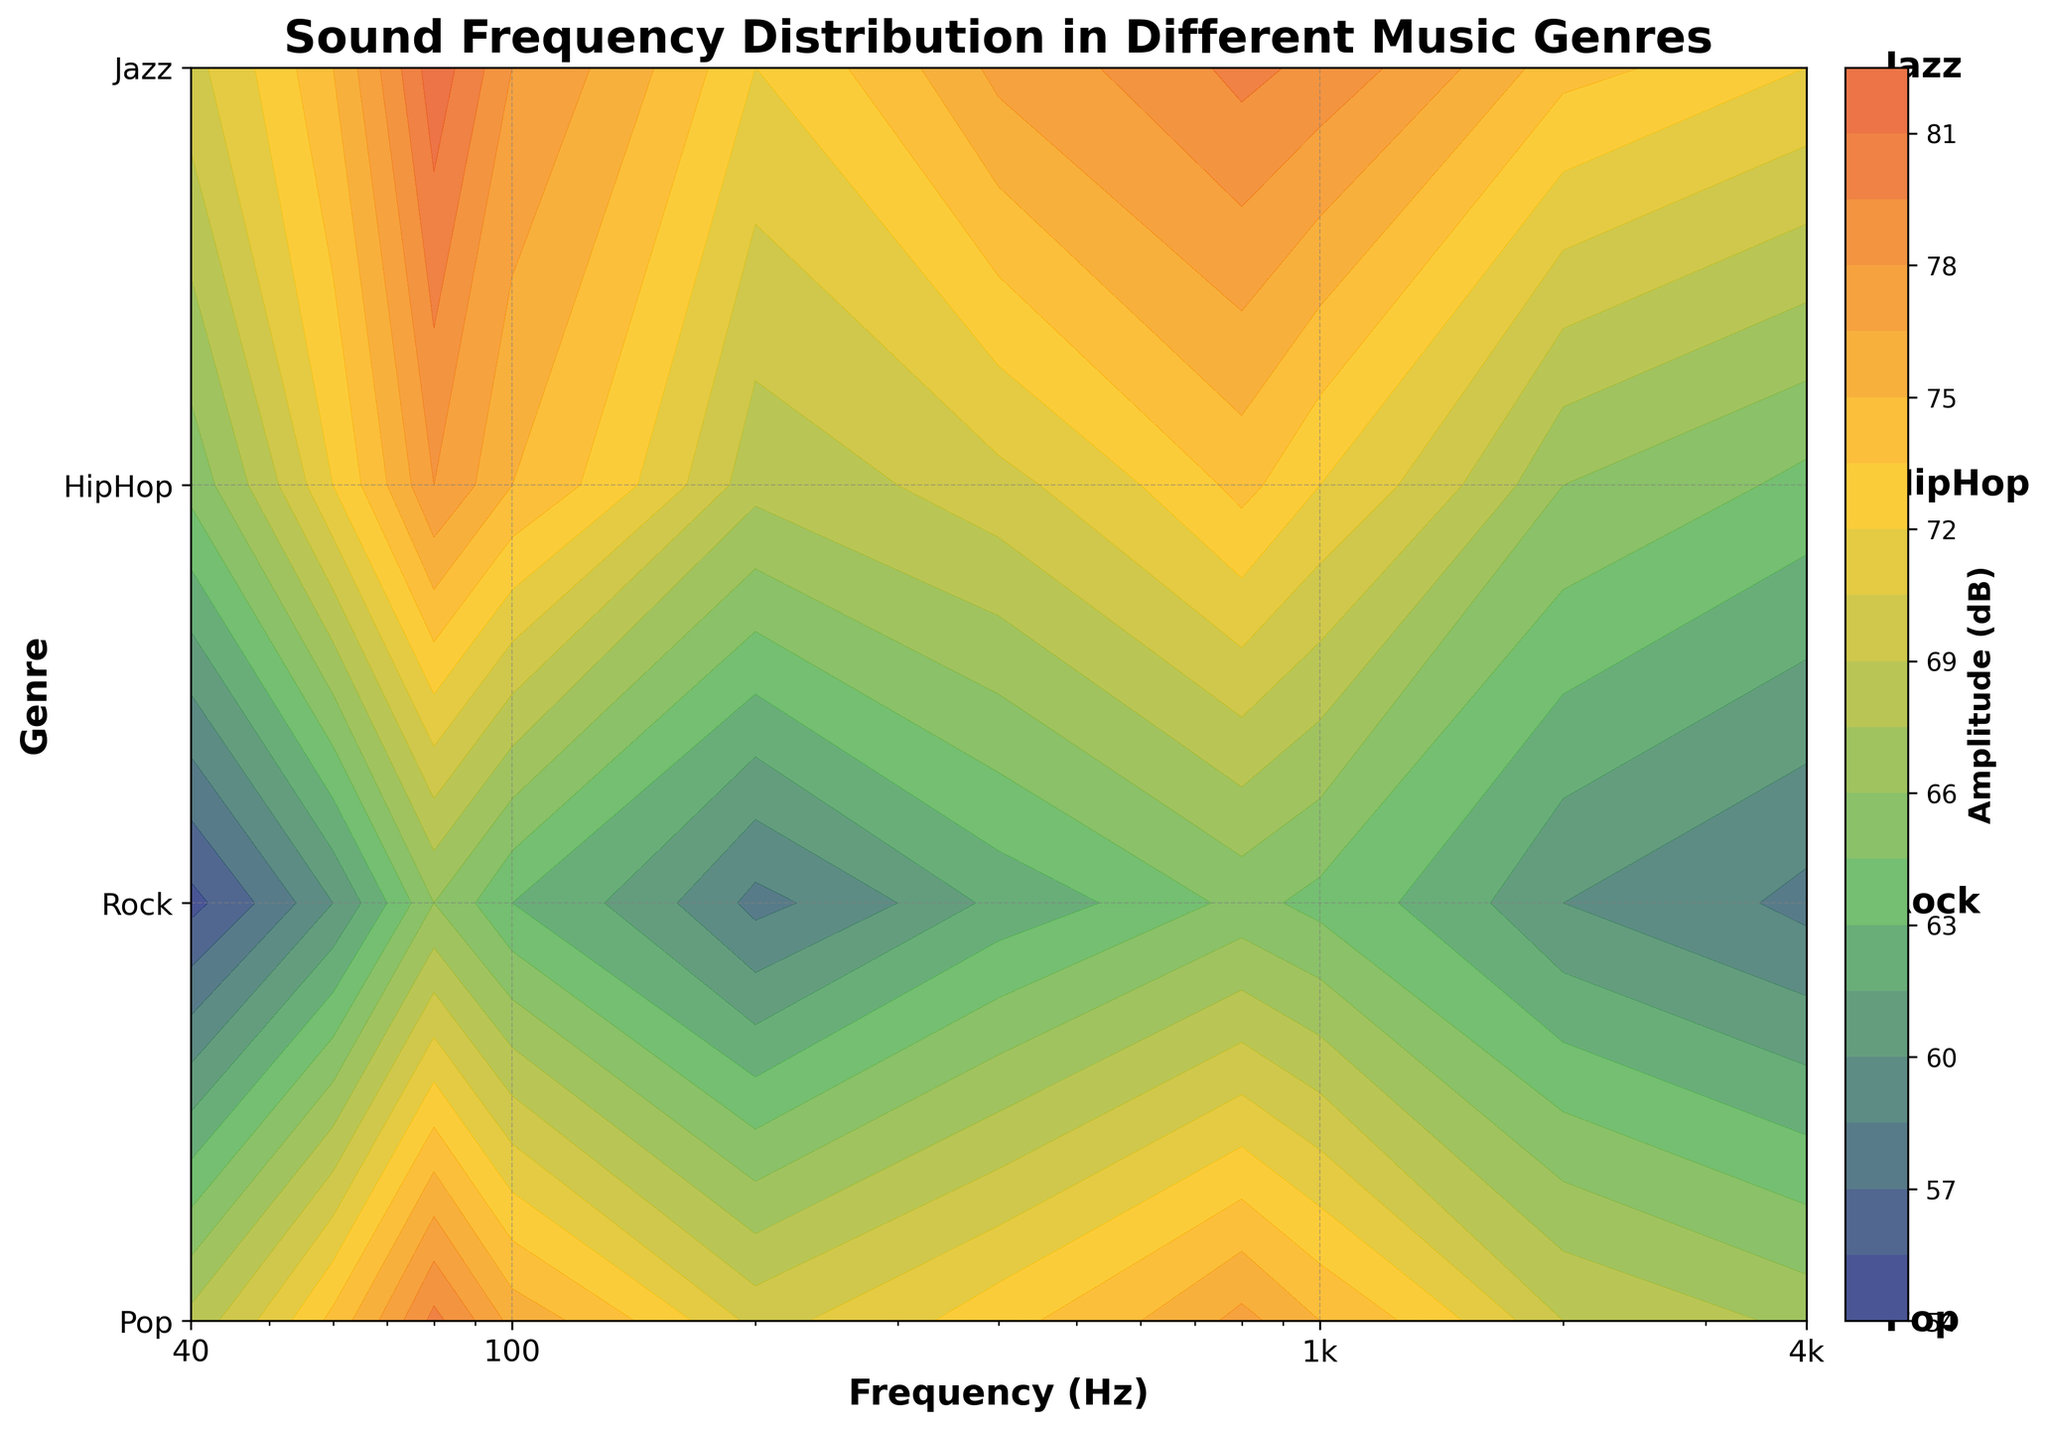Which genre has the highest amplitude at 80 Hz? By looking at the contour plot at the frequency 80 Hz, Rock shows the highest amplitude compared to other genres at this frequency.
Answer: Rock What's the title of the plot? The title is written on top of the figure. It clearly labels the subject of the plot.
Answer: Sound Frequency Distribution in Different Music Genres How does the amplitude of Pop at 1000 Hz compare to the amplitude of Rock at 1000 Hz? By observing the 1000 Hz frequency line, Pop has an amplitude of 72 dB while Rock has an amplitude of 79 dB. Hence, Rock's amplitude is higher.
Answer: Rock has a higher amplitude Which genre shows the lowest amplitude at 40 Hz? By examining the 40 Hz data points, Jazz shows the lowest amplitude compared to other genres at this frequency.
Answer: Jazz What are the x-axis and y-axis labels? The labels of the axes are provided near them; the x-axis is labeled as 'Frequency (Hz)' and the y-axis as 'Genre'.
Answer: x-axis: Frequency (Hz), y-axis: Genre Can you identify which genre shows the most consistent amplitude across all frequencies? By examining the contour lines, Jazz shows the most consistent amplitude with narrow contour spacing across the frequency range, indicating minimal change in amplitude.
Answer: Jazz What color gradient is used in the contour plot? The color gradient progresses from dark blue to green, yellow, and then orange, as evident from the colormap on the right.
Answer: Dark blue to green, yellow, and orange What's the approximate amplitude range for HipHop at 400 to 1000 Hz? Observing the amplitude values within the range 400 to 1000 Hz, HipHop's amplitude varies approximately between 73 dB and 77 dB.
Answer: 73 dB to 77 dB Which genre has the greatest amplitude difference between 40 Hz and 4000 Hz? By comparing the contour lines at 40 Hz and 4000 Hz for each genre, Rock shows the largest difference in amplitude values from 70 dB to 72 dB.
Answer: Rock How is the frequency scale presented on the x-axis? The x-axis frequency is presented on a logarithmic scale, as visible from the ticks and their exponential progression (e.g., 40, 100, 1000, 4000).
Answer: Logarithmic scale 